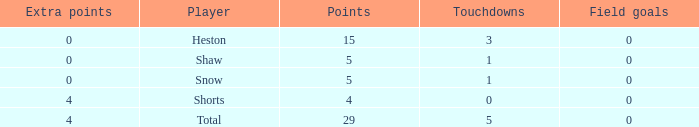What is the total number of field goals a player had when there were more than 0 extra points and there were 5 touchdowns? 1.0. 